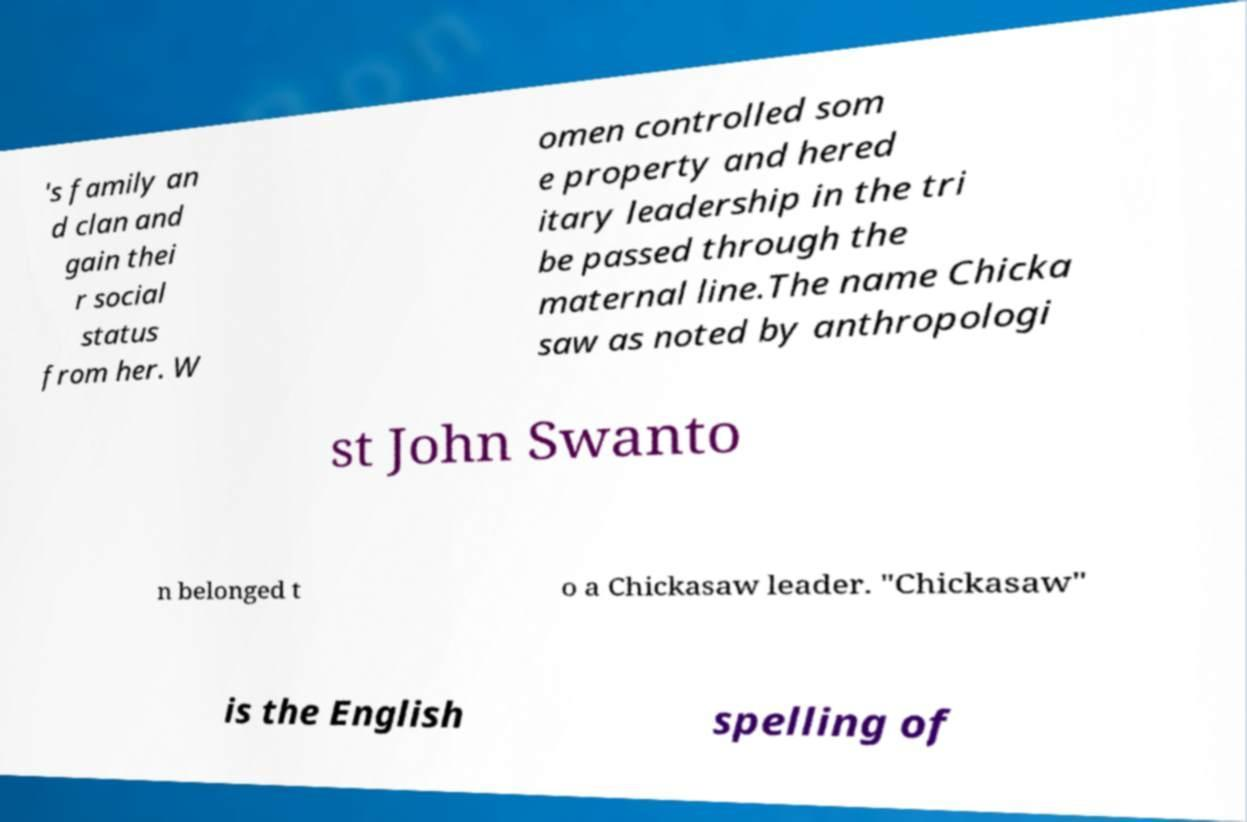Could you extract and type out the text from this image? 's family an d clan and gain thei r social status from her. W omen controlled som e property and hered itary leadership in the tri be passed through the maternal line.The name Chicka saw as noted by anthropologi st John Swanto n belonged t o a Chickasaw leader. "Chickasaw" is the English spelling of 